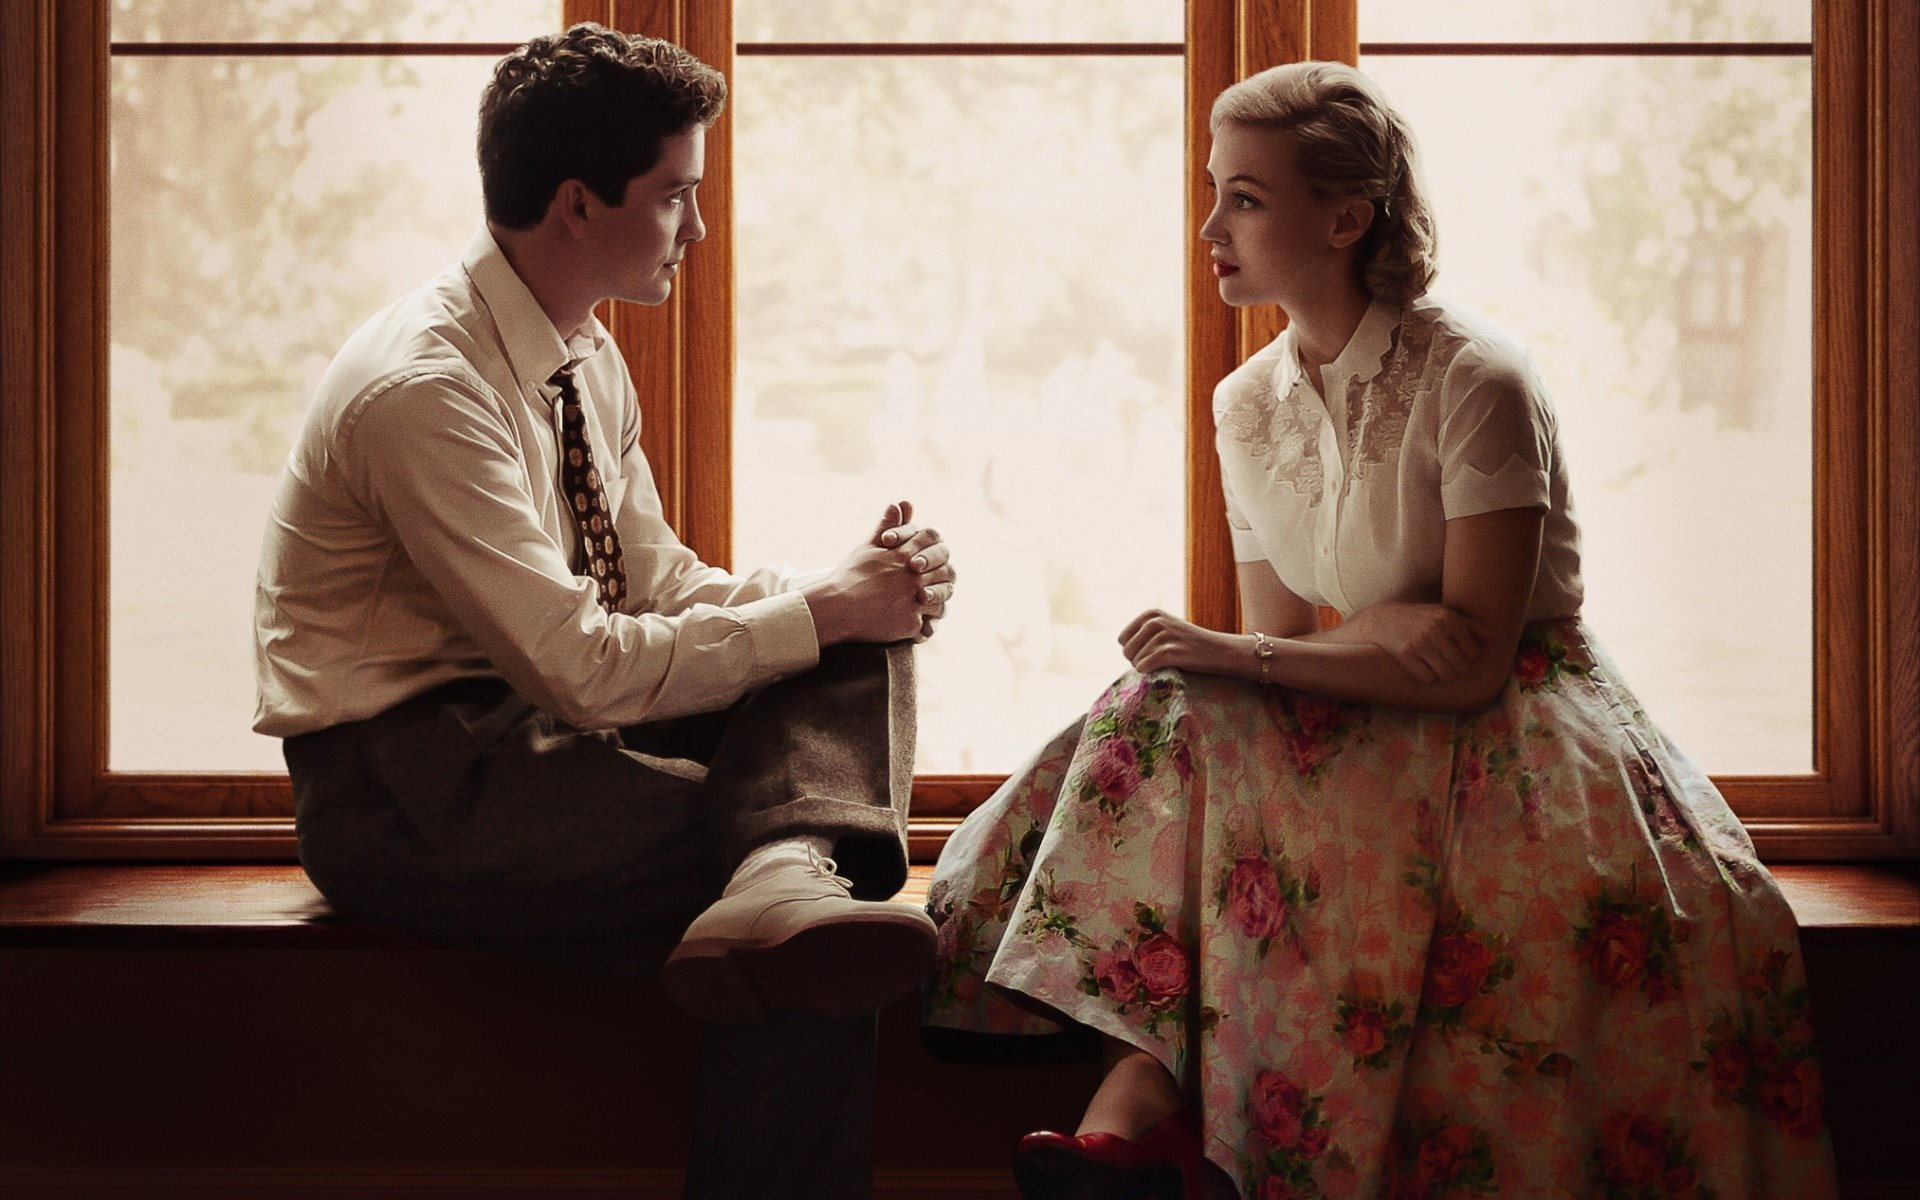What might be the relationship between these two individuals based on their body language and expressions? The body language and expressions of the two individuals suggest a close, intimate relationship, possibly romantic or deeply platonic. Their seating closely on the window sill, the way they hold hands, and their direct gaze into each other's eyes signify a strong connection and mutual understanding. The seriousness of their expressions indicates they might be discussing something significant or personal, highlighting the depth of their bond. Could the setting imply anything about the time period or context of this interaction? The setting, with its vintage architectural details and the fashion sense—particularly the woman's floral skirt and lace blouse—suggests a mid-20th century timeframe. This era is often associated with a certain formal elegance in dress and decor, which can be seen in this image. The serene, almost pastoral background viewed through the window could imply a setting away from the hustle of urban life, possibly in a rural or suburban locale during a peaceful, contemplative moment. 